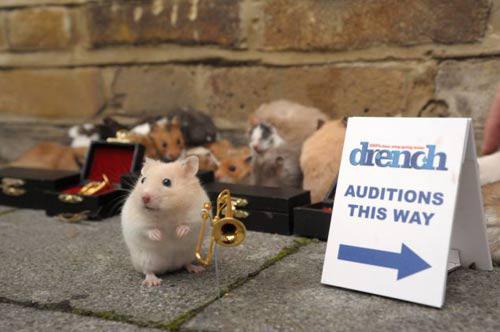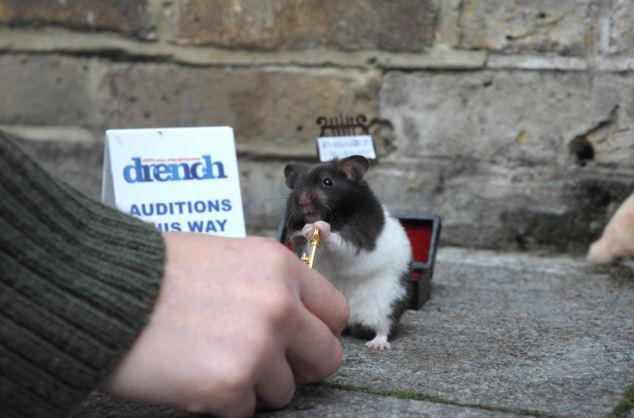The first image is the image on the left, the second image is the image on the right. Analyze the images presented: Is the assertion "Little animals are shown with tiny musical instruments and an audition sign." valid? Answer yes or no. Yes. The first image is the image on the left, the second image is the image on the right. For the images shown, is this caption "There are only two mice and they are both wearing something on their heads." true? Answer yes or no. No. 